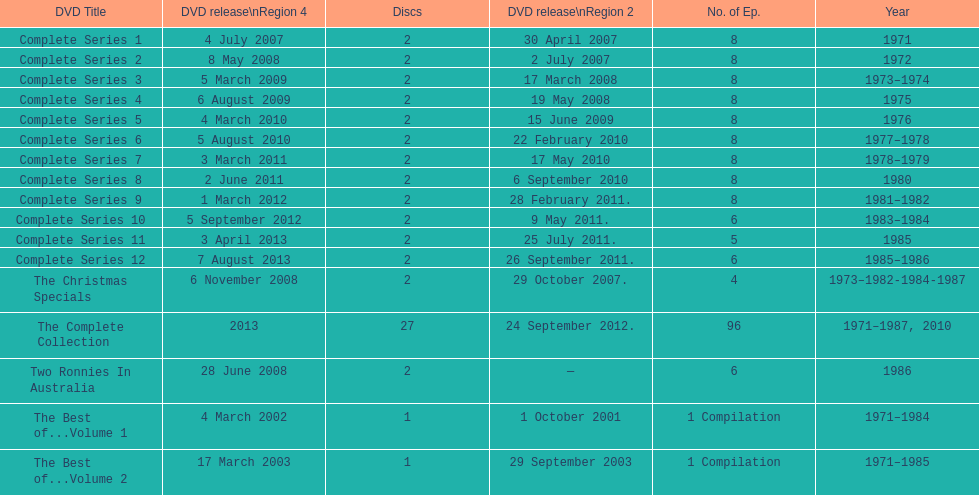The television show "the two ronnies" ran for a total of how many seasons? 12. 